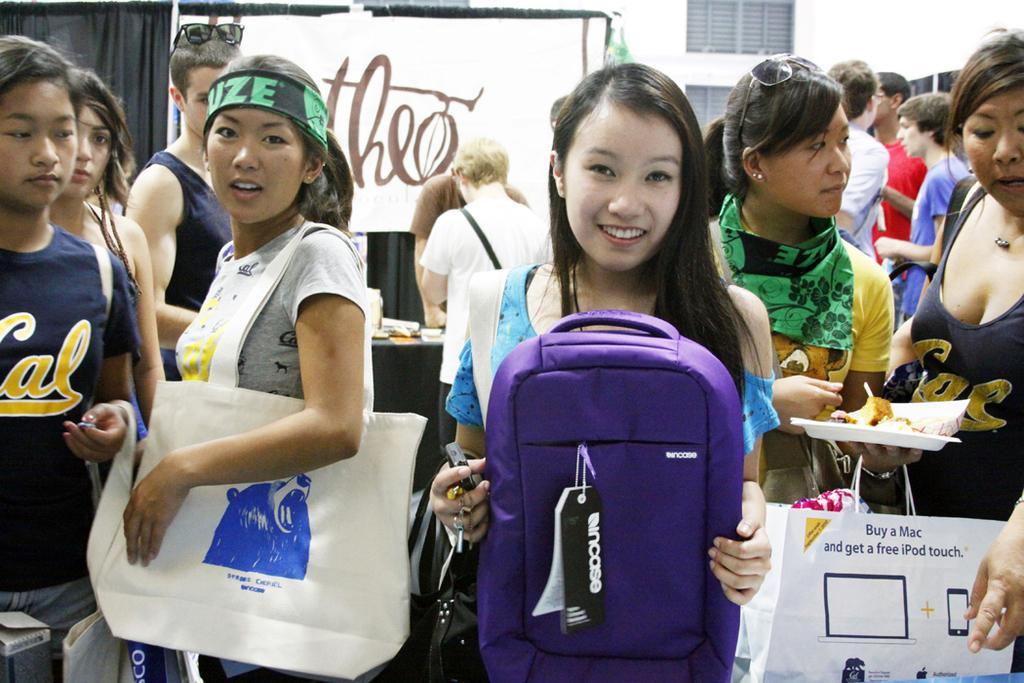Can you describe this image briefly? In this image I can see group of people standing. The person in front holding a bag which is in purple color and I can see the other bag in white color. Background I can see a board and building in white color. 